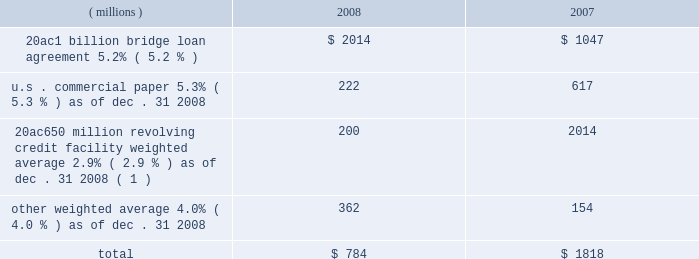Notes to the consolidated financial statements on march 18 , 2008 , ppg completed a public offering of $ 600 million in aggregate principal amount of its 5.75% ( 5.75 % ) notes due 2013 ( the 201c2013 notes 201d ) , $ 700 million in aggregate principal amount of its 6.65% ( 6.65 % ) notes due 2018 ( the 201c2018 notes 201d ) and $ 250 million in aggregate principal amount of its 7.70% ( 7.70 % ) notes due 2038 ( the 201c2038 notes 201d and , together with the 2013 notes and the 2018 notes , the 201cnotes 201d ) .
The notes were offered by the company pursuant to its existing shelf registration .
The proceeds of this offering of $ 1538 million ( net of discount and issuance costs ) and additional borrowings of $ 195 million under the 20ac650 million revolving credit facility were used to repay existing debt , including certain short-term debt and the amounts outstanding under the 20ac1 billion bridge loan .
No further amounts can be borrowed under the 20ac1 billion bridge loan .
The discount and issuance costs related to the notes , which totaled $ 12 million , will be amortized to interest expense over the respective lives of the notes .
Short-term debt outstanding as of december 31 , 2008 and 2007 , was as follows : ( millions ) 2008 2007 .
Total $ 784 $ 1818 ( 1 ) borrowings under this facility have a term of 30 days and can be rolled over monthly until the facility expires in 2010 .
Ppg is in compliance with the restrictive covenants under its various credit agreements , loan agreements and indentures .
The company 2019s revolving credit agreements include a financial ratio covenant .
The covenant requires that the amount of total indebtedness not exceed 60% ( 60 % ) of the company 2019s total capitalization excluding the portion of accumulated other comprehensive income ( loss ) related to pensions and other postretirement benefit adjustments .
As of december 31 , 2008 , total indebtedness was 45% ( 45 % ) of the company 2019s total capitalization excluding the portion of accumulated other comprehensive income ( loss ) related to pensions and other postretirement benefit adjustments .
Additionally , substantially all of the company 2019s debt agreements contain customary cross- default provisions .
Those provisions generally provide that a default on a debt service payment of $ 10 million or more for longer than the grace period provided ( usually 10 days ) under one agreement may result in an event of default under other agreements .
None of the company 2019s primary debt obligations are secured or guaranteed by the company 2019s affiliates .
Interest payments in 2008 , 2007 and 2006 totaled $ 228 million , $ 102 million and $ 90 million , respectively .
Rental expense for operating leases was $ 267 million , $ 188 million and $ 161 million in 2008 , 2007 and 2006 , respectively .
The primary leased assets include paint stores , transportation equipment , warehouses and other distribution facilities , and office space , including the company 2019s corporate headquarters located in pittsburgh , pa .
Minimum lease commitments for operating leases that have initial or remaining lease terms in excess of one year as of december 31 , 2008 , are ( in millions ) $ 126 in 2009 , $ 107 in 2010 , $ 82 in 2011 , $ 65 in 2012 , $ 51 in 2013 and $ 202 thereafter .
The company had outstanding letters of credit of $ 82 million as of december 31 , 2008 .
The letters of credit secure the company 2019s performance to third parties under certain self-insurance programs and other commitments made in the ordinary course of business .
As of december 31 , 2008 and 2007 guarantees outstanding were $ 70 million .
The guarantees relate primarily to debt of certain entities in which ppg has an ownership interest and selected customers of certain of the company 2019s businesses .
A portion of such debt is secured by the assets of the related entities .
The carrying values of these guarantees were $ 9 million and $ 3 million as of december 31 , 2008 and 2007 , respectively , and the fair values were $ 40 million and $ 17 million , as of december 31 , 2008 and 2007 , respectively .
The company does not believe any loss related to these letters of credit or guarantees is likely .
10 .
Financial instruments , excluding derivative financial instruments included in ppg 2019s financial instrument portfolio are cash and cash equivalents , cash held in escrow , marketable equity securities , company-owned life insurance and short- and long-term debt instruments .
The fair values of the financial instruments approximated their carrying values , in the aggregate , except for long-term long-term debt ( excluding capital lease obligations ) , had carrying and fair values totaling $ 3122 million and $ 3035 million , respectively , as of december 31 , 2008 .
The corresponding amounts as of december 31 , 2007 , were $ 1201 million and $ 1226 million , respectively .
The fair values of the debt instruments were based on discounted cash flows and interest rates currently available to the company for instruments of the same remaining maturities .
2008 ppg annual report and form 10-k 45 .
What would rental expense for operating leases be in millions in 2009 with the same percentage increase in leases as in 2008? 
Computations: ((267 / 188) * 267)
Answer: 379.19681. 